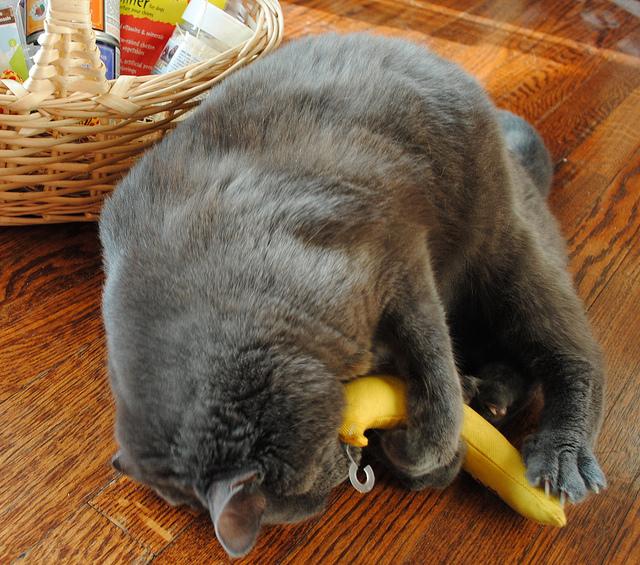Is this cat a stray?
Short answer required. No. What is the cat playing with?
Keep it brief. Banana. What are the colorful objects to the left of the cats?
Be succinct. Bottles. Is there a phone in the basket?
Be succinct. No. 